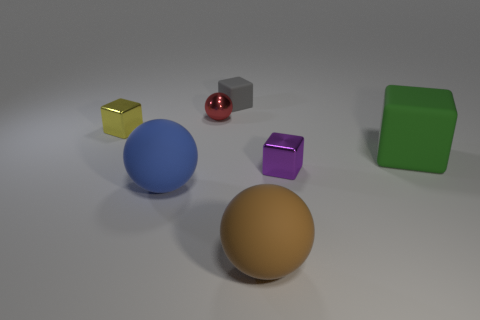Subtract all gray cubes. How many cubes are left? 3 Subtract all tiny matte cubes. How many cubes are left? 3 Subtract all cyan cubes. Subtract all cyan balls. How many cubes are left? 4 Add 2 rubber spheres. How many objects exist? 9 Add 6 purple cubes. How many purple cubes are left? 7 Add 3 purple metal objects. How many purple metal objects exist? 4 Subtract 0 brown blocks. How many objects are left? 7 Subtract all spheres. How many objects are left? 4 Subtract all big blue matte balls. Subtract all small metal things. How many objects are left? 3 